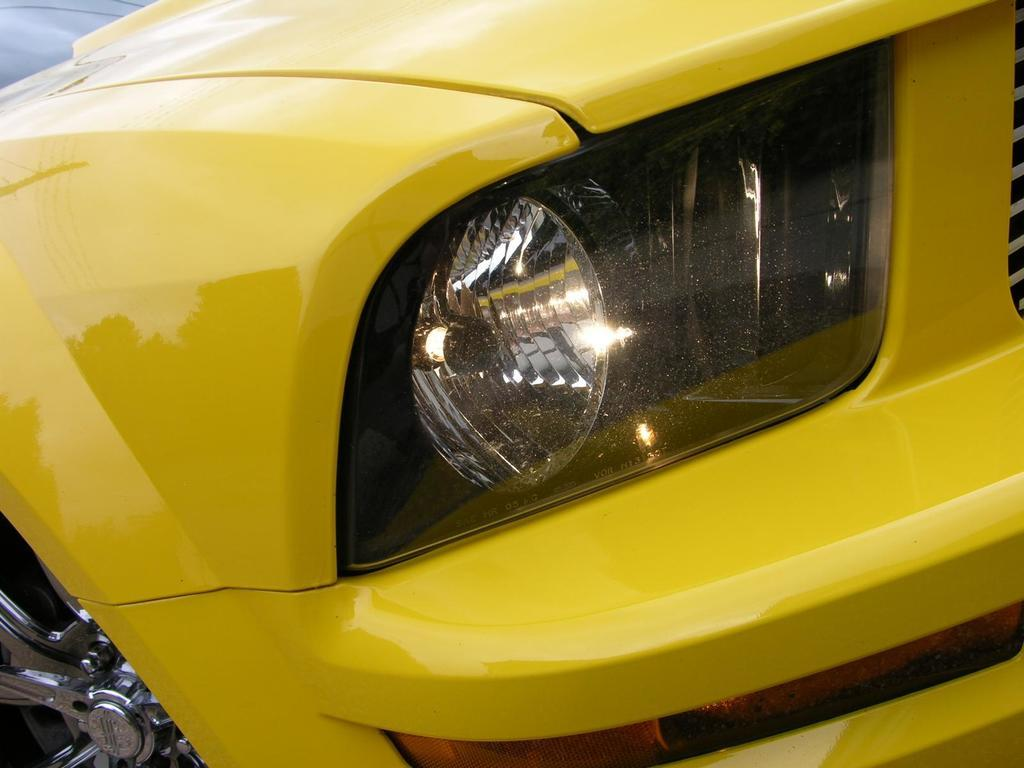What color is the car in the image? The car in the image is yellow. Where is the car located in the image? The car is in the center of the image. Reasoning: Let' Let's think step by step in order to produce the conversation. We start by identifying the main subject in the image, which is the yellow car. Then, we describe its location in the image, which is in the center. We avoid asking any questions that cannot be answered definitively with the given facts and ensure that the language is simple and clear. Absurd Question/Answer: Does the car in the image belong to a specific team or organization? There is no indication in the image that the car in the image is part of a heat-resistant team? Does the car in the image belong to a specific team or organization? There is no indication in the image that the car in the image is part of a team or organization. --- Facts: 1. There is a person holding a book in the image. 2. The book has a blue cover. 3. The person is sitting on a chair. 4. There is a table next to the chair. 5. The table has a lamp on it. Absurd Topics: ocean, dance, elephant Conversation: What is the person in the image holding? The person in the image is holding a book. What color is the book's cover? The book's cover is blue. Where is the person sitting in the image? The person is sitting on a chair. What is located next to the chair? There is a table next to the chair. What object is on the table? The table has a lamp on it. Reasoning: Let's think step by step in order to produce the conversation. We start by identifying the main subject in the image, which is the person holding a book. Then, we describe the book's color and the person's location. Next, we mention the presence of a table and its contents. Each question is designed to elicit a specific detail about the image 